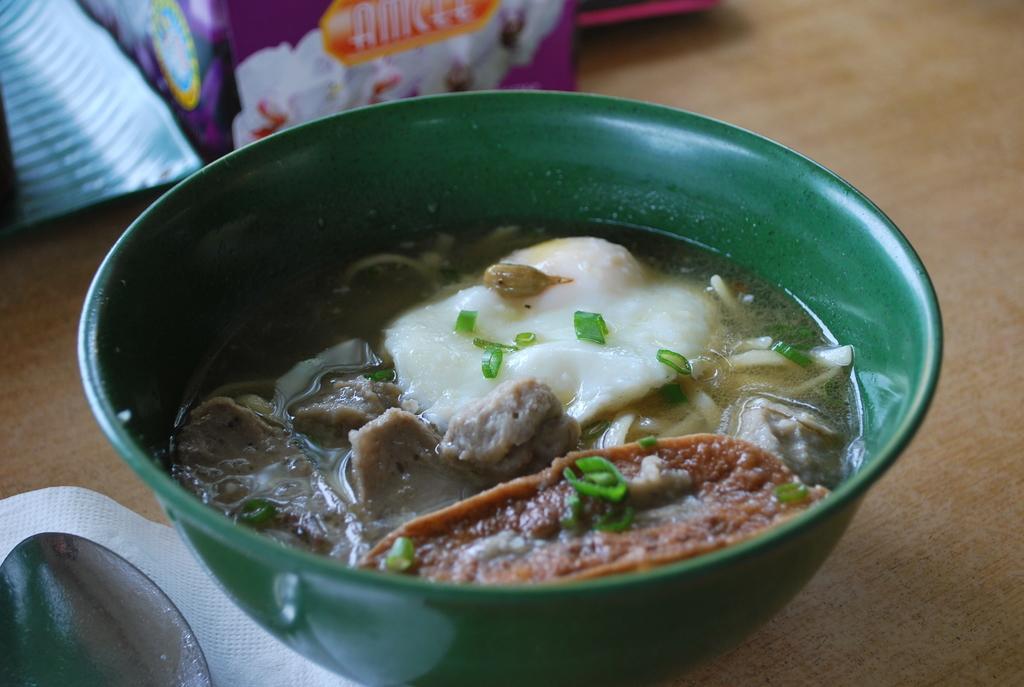Can you describe this image briefly? In this image we can see food in a bowl, tissue paper, spoon, and packets on a wooden platform. 